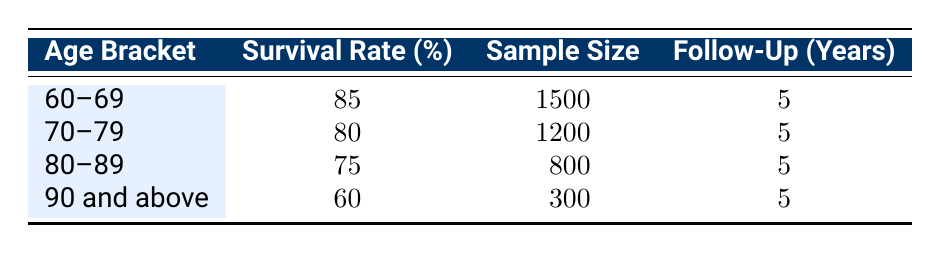What is the survival rate for patients aged 60-69? The survival rate for the age bracket 60-69 is directly indicated in the table as 85%.
Answer: 85% How many patients were included in the 70-79 age group? The sample size for the 70-79 age group is provided in the table, which states it is 1200.
Answer: 1200 What is the average survival rate for the age brackets 80-89 and 90 and above? The survival rates for these age brackets are 75% and 60%, respectively. The average is calculated by adding these two rates (75 + 60) and dividing by 2, resulting in (135/2 = 67.5).
Answer: 67.5 Is the survival rate for patients aged 80-89 greater than that for patients aged 70-79? The survival rate for patients aged 80-89 is 75%, while for those aged 70-79, it's 80%. Since 75% is less than 80%, the answer is no.
Answer: No How many more patients were included in the 60-69 age group compared to the 90 and above age group? The sample size for the 60-69 age group is 1500, and for the 90 and above group, it is 300. To find the difference, subtract the smaller sample size from the larger: 1500 - 300 = 1200.
Answer: 1200 What is the total sample size of all age brackets combined? The total sample size is computed by adding together the sample sizes from all the age brackets: 1500 + 1200 + 800 + 300 = 2800.
Answer: 2800 Is the survival rate for any age bracket below 70%? The only age bracket with a survival rate below 70% is the one for patients aged 90 and above, which is at 60%.
Answer: Yes What is the survival rate for the youngest age bracket compared to the oldest? The survival rate for the 60-69 age bracket is 85%, whereas for the 90 and above group, it is 60%. Since 85% is greater than 60%, the younger group has a higher survival rate.
Answer: Yes 